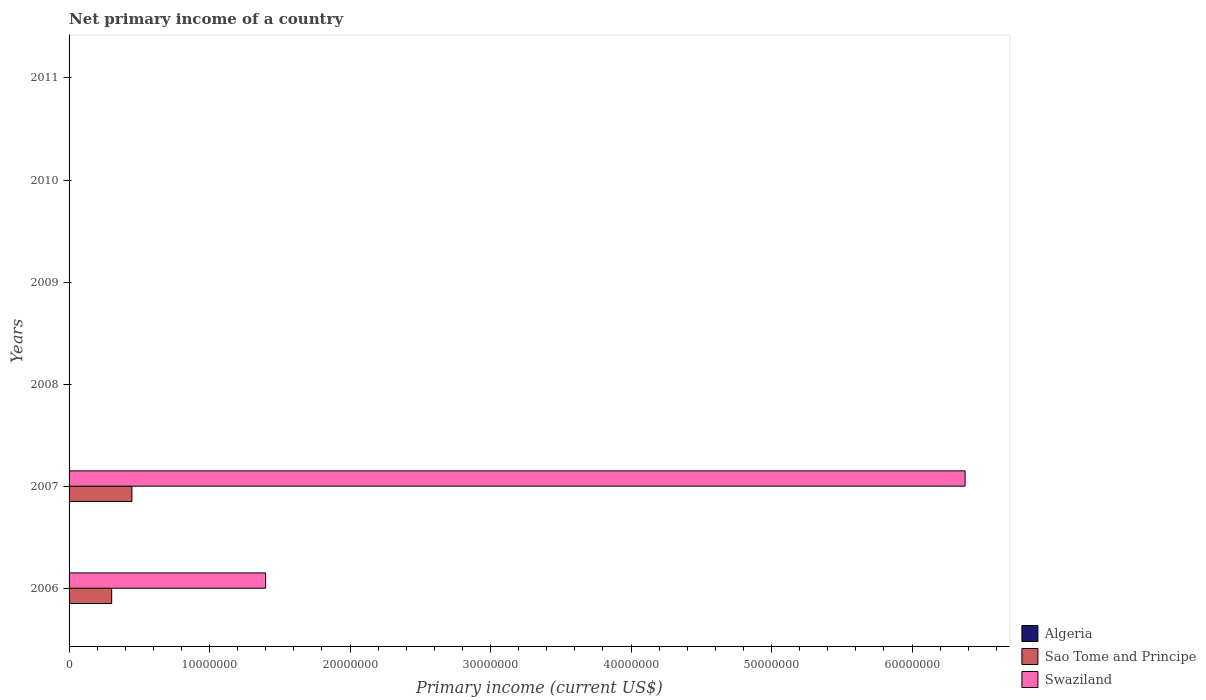How many different coloured bars are there?
Your response must be concise. 2. What is the label of the 1st group of bars from the top?
Provide a short and direct response. 2011. Across all years, what is the maximum primary income in Swaziland?
Your response must be concise. 6.38e+07. Across all years, what is the minimum primary income in Swaziland?
Provide a short and direct response. 0. In which year was the primary income in Swaziland maximum?
Provide a succinct answer. 2007. What is the total primary income in Swaziland in the graph?
Your answer should be very brief. 7.78e+07. What is the difference between the primary income in Sao Tome and Principe in 2006 and that in 2007?
Provide a succinct answer. -1.44e+06. What is the average primary income in Swaziland per year?
Offer a very short reply. 1.30e+07. In the year 2006, what is the difference between the primary income in Sao Tome and Principe and primary income in Swaziland?
Give a very brief answer. -1.10e+07. In how many years, is the primary income in Sao Tome and Principe greater than 4000000 US$?
Provide a short and direct response. 1. What is the difference between the highest and the lowest primary income in Sao Tome and Principe?
Keep it short and to the point. 4.47e+06. Are all the bars in the graph horizontal?
Offer a very short reply. Yes. How many years are there in the graph?
Offer a very short reply. 6. Are the values on the major ticks of X-axis written in scientific E-notation?
Provide a short and direct response. No. Does the graph contain any zero values?
Make the answer very short. Yes. Does the graph contain grids?
Provide a short and direct response. No. Where does the legend appear in the graph?
Offer a very short reply. Bottom right. How many legend labels are there?
Keep it short and to the point. 3. What is the title of the graph?
Make the answer very short. Net primary income of a country. What is the label or title of the X-axis?
Provide a succinct answer. Primary income (current US$). What is the label or title of the Y-axis?
Your answer should be compact. Years. What is the Primary income (current US$) in Algeria in 2006?
Your answer should be compact. 0. What is the Primary income (current US$) in Sao Tome and Principe in 2006?
Offer a very short reply. 3.03e+06. What is the Primary income (current US$) in Swaziland in 2006?
Give a very brief answer. 1.40e+07. What is the Primary income (current US$) of Algeria in 2007?
Provide a succinct answer. 0. What is the Primary income (current US$) in Sao Tome and Principe in 2007?
Provide a short and direct response. 4.47e+06. What is the Primary income (current US$) in Swaziland in 2007?
Provide a succinct answer. 6.38e+07. What is the Primary income (current US$) in Algeria in 2008?
Your response must be concise. 0. What is the Primary income (current US$) in Swaziland in 2008?
Make the answer very short. 0. What is the Primary income (current US$) of Algeria in 2009?
Your answer should be very brief. 0. What is the Primary income (current US$) in Swaziland in 2009?
Make the answer very short. 0. What is the Primary income (current US$) of Algeria in 2011?
Your answer should be very brief. 0. What is the Primary income (current US$) in Sao Tome and Principe in 2011?
Make the answer very short. 0. What is the Primary income (current US$) in Swaziland in 2011?
Make the answer very short. 0. Across all years, what is the maximum Primary income (current US$) of Sao Tome and Principe?
Keep it short and to the point. 4.47e+06. Across all years, what is the maximum Primary income (current US$) in Swaziland?
Provide a succinct answer. 6.38e+07. Across all years, what is the minimum Primary income (current US$) of Sao Tome and Principe?
Keep it short and to the point. 0. Across all years, what is the minimum Primary income (current US$) of Swaziland?
Your answer should be very brief. 0. What is the total Primary income (current US$) in Sao Tome and Principe in the graph?
Your answer should be very brief. 7.51e+06. What is the total Primary income (current US$) in Swaziland in the graph?
Make the answer very short. 7.78e+07. What is the difference between the Primary income (current US$) in Sao Tome and Principe in 2006 and that in 2007?
Provide a short and direct response. -1.44e+06. What is the difference between the Primary income (current US$) of Swaziland in 2006 and that in 2007?
Offer a very short reply. -4.98e+07. What is the difference between the Primary income (current US$) in Sao Tome and Principe in 2006 and the Primary income (current US$) in Swaziland in 2007?
Keep it short and to the point. -6.07e+07. What is the average Primary income (current US$) in Algeria per year?
Provide a short and direct response. 0. What is the average Primary income (current US$) in Sao Tome and Principe per year?
Make the answer very short. 1.25e+06. What is the average Primary income (current US$) in Swaziland per year?
Make the answer very short. 1.30e+07. In the year 2006, what is the difference between the Primary income (current US$) in Sao Tome and Principe and Primary income (current US$) in Swaziland?
Ensure brevity in your answer.  -1.10e+07. In the year 2007, what is the difference between the Primary income (current US$) in Sao Tome and Principe and Primary income (current US$) in Swaziland?
Keep it short and to the point. -5.93e+07. What is the ratio of the Primary income (current US$) of Sao Tome and Principe in 2006 to that in 2007?
Keep it short and to the point. 0.68. What is the ratio of the Primary income (current US$) of Swaziland in 2006 to that in 2007?
Offer a terse response. 0.22. What is the difference between the highest and the lowest Primary income (current US$) in Sao Tome and Principe?
Provide a short and direct response. 4.47e+06. What is the difference between the highest and the lowest Primary income (current US$) of Swaziland?
Give a very brief answer. 6.38e+07. 